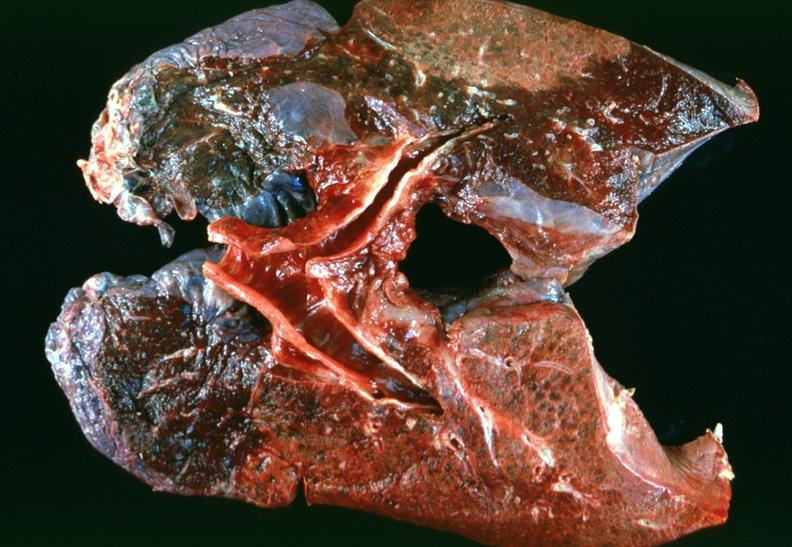does gastrointestinal show lung, emphysema severe with bullae?
Answer the question using a single word or phrase. No 